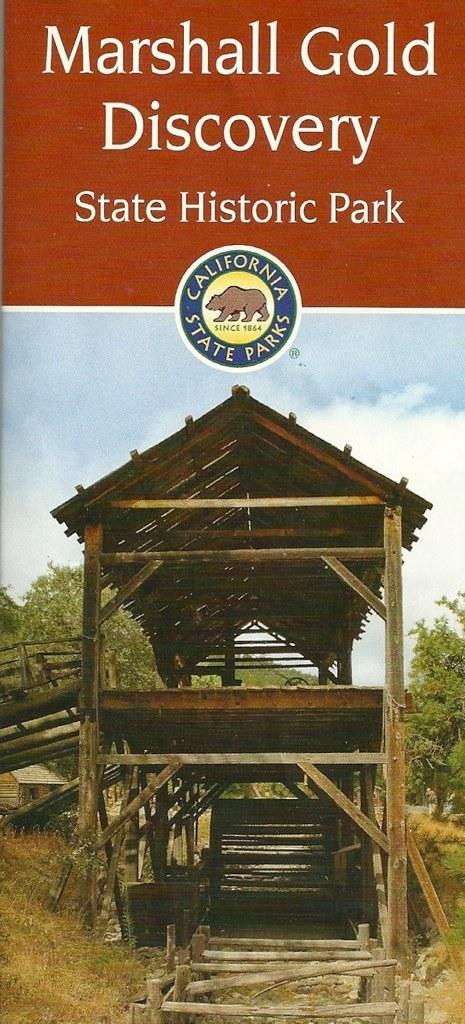Can you describe this image briefly? In this image I can see there is a wooden bridge and there is a roof at the top of the bridge and there are few wooden sticks on the floor and there is grass on the floor and in the backdrop there are trees and the sky is clear. There is something written on the image and there is a logo at the center of the image. 